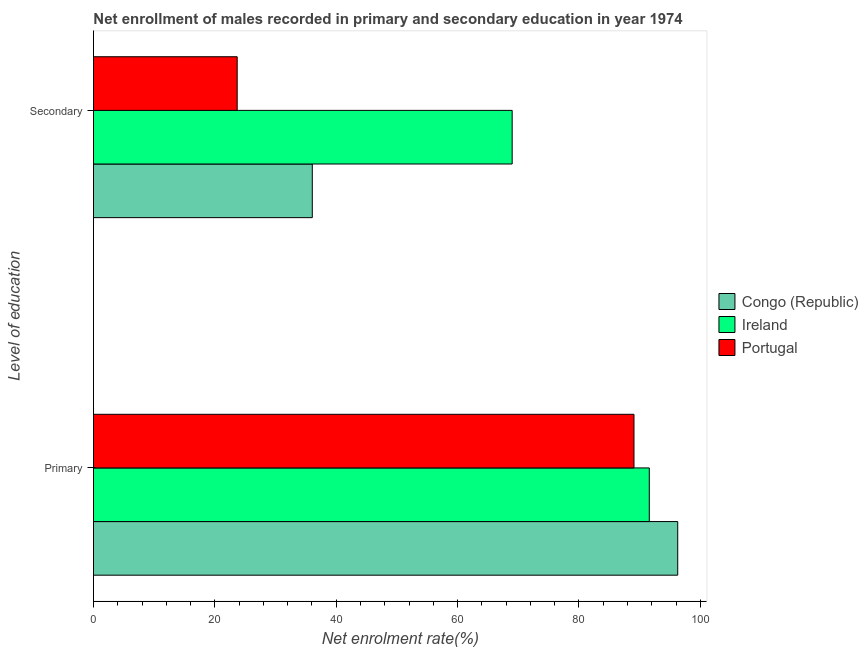How many different coloured bars are there?
Provide a succinct answer. 3. How many bars are there on the 2nd tick from the bottom?
Make the answer very short. 3. What is the label of the 2nd group of bars from the top?
Offer a very short reply. Primary. What is the enrollment rate in secondary education in Congo (Republic)?
Offer a terse response. 36.06. Across all countries, what is the maximum enrollment rate in primary education?
Give a very brief answer. 96.28. Across all countries, what is the minimum enrollment rate in primary education?
Your answer should be compact. 89.07. In which country was the enrollment rate in primary education maximum?
Provide a succinct answer. Congo (Republic). In which country was the enrollment rate in secondary education minimum?
Keep it short and to the point. Portugal. What is the total enrollment rate in secondary education in the graph?
Ensure brevity in your answer.  128.74. What is the difference between the enrollment rate in primary education in Ireland and that in Congo (Republic)?
Ensure brevity in your answer.  -4.69. What is the difference between the enrollment rate in secondary education in Ireland and the enrollment rate in primary education in Portugal?
Offer a very short reply. -20.07. What is the average enrollment rate in primary education per country?
Your answer should be very brief. 92.32. What is the difference between the enrollment rate in primary education and enrollment rate in secondary education in Ireland?
Your answer should be very brief. 22.6. In how many countries, is the enrollment rate in primary education greater than 56 %?
Provide a short and direct response. 3. What is the ratio of the enrollment rate in secondary education in Portugal to that in Congo (Republic)?
Offer a terse response. 0.66. Is the enrollment rate in primary education in Portugal less than that in Ireland?
Your answer should be very brief. Yes. What does the 2nd bar from the top in Secondary represents?
Your response must be concise. Ireland. What does the 1st bar from the bottom in Secondary represents?
Ensure brevity in your answer.  Congo (Republic). How many bars are there?
Ensure brevity in your answer.  6. Are the values on the major ticks of X-axis written in scientific E-notation?
Ensure brevity in your answer.  No. Does the graph contain any zero values?
Your answer should be very brief. No. Does the graph contain grids?
Offer a terse response. No. Where does the legend appear in the graph?
Give a very brief answer. Center right. How many legend labels are there?
Your answer should be very brief. 3. What is the title of the graph?
Offer a terse response. Net enrollment of males recorded in primary and secondary education in year 1974. What is the label or title of the X-axis?
Offer a very short reply. Net enrolment rate(%). What is the label or title of the Y-axis?
Provide a succinct answer. Level of education. What is the Net enrolment rate(%) in Congo (Republic) in Primary?
Your answer should be very brief. 96.28. What is the Net enrolment rate(%) of Ireland in Primary?
Offer a terse response. 91.59. What is the Net enrolment rate(%) in Portugal in Primary?
Provide a short and direct response. 89.07. What is the Net enrolment rate(%) of Congo (Republic) in Secondary?
Your answer should be compact. 36.06. What is the Net enrolment rate(%) of Ireland in Secondary?
Provide a succinct answer. 69. What is the Net enrolment rate(%) of Portugal in Secondary?
Provide a short and direct response. 23.68. Across all Level of education, what is the maximum Net enrolment rate(%) of Congo (Republic)?
Your response must be concise. 96.28. Across all Level of education, what is the maximum Net enrolment rate(%) of Ireland?
Offer a terse response. 91.59. Across all Level of education, what is the maximum Net enrolment rate(%) in Portugal?
Provide a short and direct response. 89.07. Across all Level of education, what is the minimum Net enrolment rate(%) in Congo (Republic)?
Give a very brief answer. 36.06. Across all Level of education, what is the minimum Net enrolment rate(%) of Ireland?
Your response must be concise. 69. Across all Level of education, what is the minimum Net enrolment rate(%) of Portugal?
Your answer should be compact. 23.68. What is the total Net enrolment rate(%) in Congo (Republic) in the graph?
Ensure brevity in your answer.  132.34. What is the total Net enrolment rate(%) of Ireland in the graph?
Provide a succinct answer. 160.59. What is the total Net enrolment rate(%) of Portugal in the graph?
Your answer should be compact. 112.76. What is the difference between the Net enrolment rate(%) in Congo (Republic) in Primary and that in Secondary?
Make the answer very short. 60.22. What is the difference between the Net enrolment rate(%) in Ireland in Primary and that in Secondary?
Offer a very short reply. 22.6. What is the difference between the Net enrolment rate(%) of Portugal in Primary and that in Secondary?
Ensure brevity in your answer.  65.39. What is the difference between the Net enrolment rate(%) in Congo (Republic) in Primary and the Net enrolment rate(%) in Ireland in Secondary?
Provide a short and direct response. 27.28. What is the difference between the Net enrolment rate(%) in Congo (Republic) in Primary and the Net enrolment rate(%) in Portugal in Secondary?
Keep it short and to the point. 72.6. What is the difference between the Net enrolment rate(%) of Ireland in Primary and the Net enrolment rate(%) of Portugal in Secondary?
Your answer should be very brief. 67.91. What is the average Net enrolment rate(%) in Congo (Republic) per Level of education?
Give a very brief answer. 66.17. What is the average Net enrolment rate(%) in Ireland per Level of education?
Provide a succinct answer. 80.3. What is the average Net enrolment rate(%) of Portugal per Level of education?
Your answer should be compact. 56.38. What is the difference between the Net enrolment rate(%) of Congo (Republic) and Net enrolment rate(%) of Ireland in Primary?
Provide a succinct answer. 4.69. What is the difference between the Net enrolment rate(%) in Congo (Republic) and Net enrolment rate(%) in Portugal in Primary?
Make the answer very short. 7.21. What is the difference between the Net enrolment rate(%) in Ireland and Net enrolment rate(%) in Portugal in Primary?
Provide a short and direct response. 2.52. What is the difference between the Net enrolment rate(%) in Congo (Republic) and Net enrolment rate(%) in Ireland in Secondary?
Your answer should be very brief. -32.94. What is the difference between the Net enrolment rate(%) in Congo (Republic) and Net enrolment rate(%) in Portugal in Secondary?
Offer a very short reply. 12.38. What is the difference between the Net enrolment rate(%) in Ireland and Net enrolment rate(%) in Portugal in Secondary?
Ensure brevity in your answer.  45.31. What is the ratio of the Net enrolment rate(%) in Congo (Republic) in Primary to that in Secondary?
Make the answer very short. 2.67. What is the ratio of the Net enrolment rate(%) in Ireland in Primary to that in Secondary?
Provide a short and direct response. 1.33. What is the ratio of the Net enrolment rate(%) in Portugal in Primary to that in Secondary?
Give a very brief answer. 3.76. What is the difference between the highest and the second highest Net enrolment rate(%) in Congo (Republic)?
Offer a very short reply. 60.22. What is the difference between the highest and the second highest Net enrolment rate(%) in Ireland?
Provide a succinct answer. 22.6. What is the difference between the highest and the second highest Net enrolment rate(%) in Portugal?
Ensure brevity in your answer.  65.39. What is the difference between the highest and the lowest Net enrolment rate(%) in Congo (Republic)?
Give a very brief answer. 60.22. What is the difference between the highest and the lowest Net enrolment rate(%) in Ireland?
Give a very brief answer. 22.6. What is the difference between the highest and the lowest Net enrolment rate(%) in Portugal?
Provide a short and direct response. 65.39. 